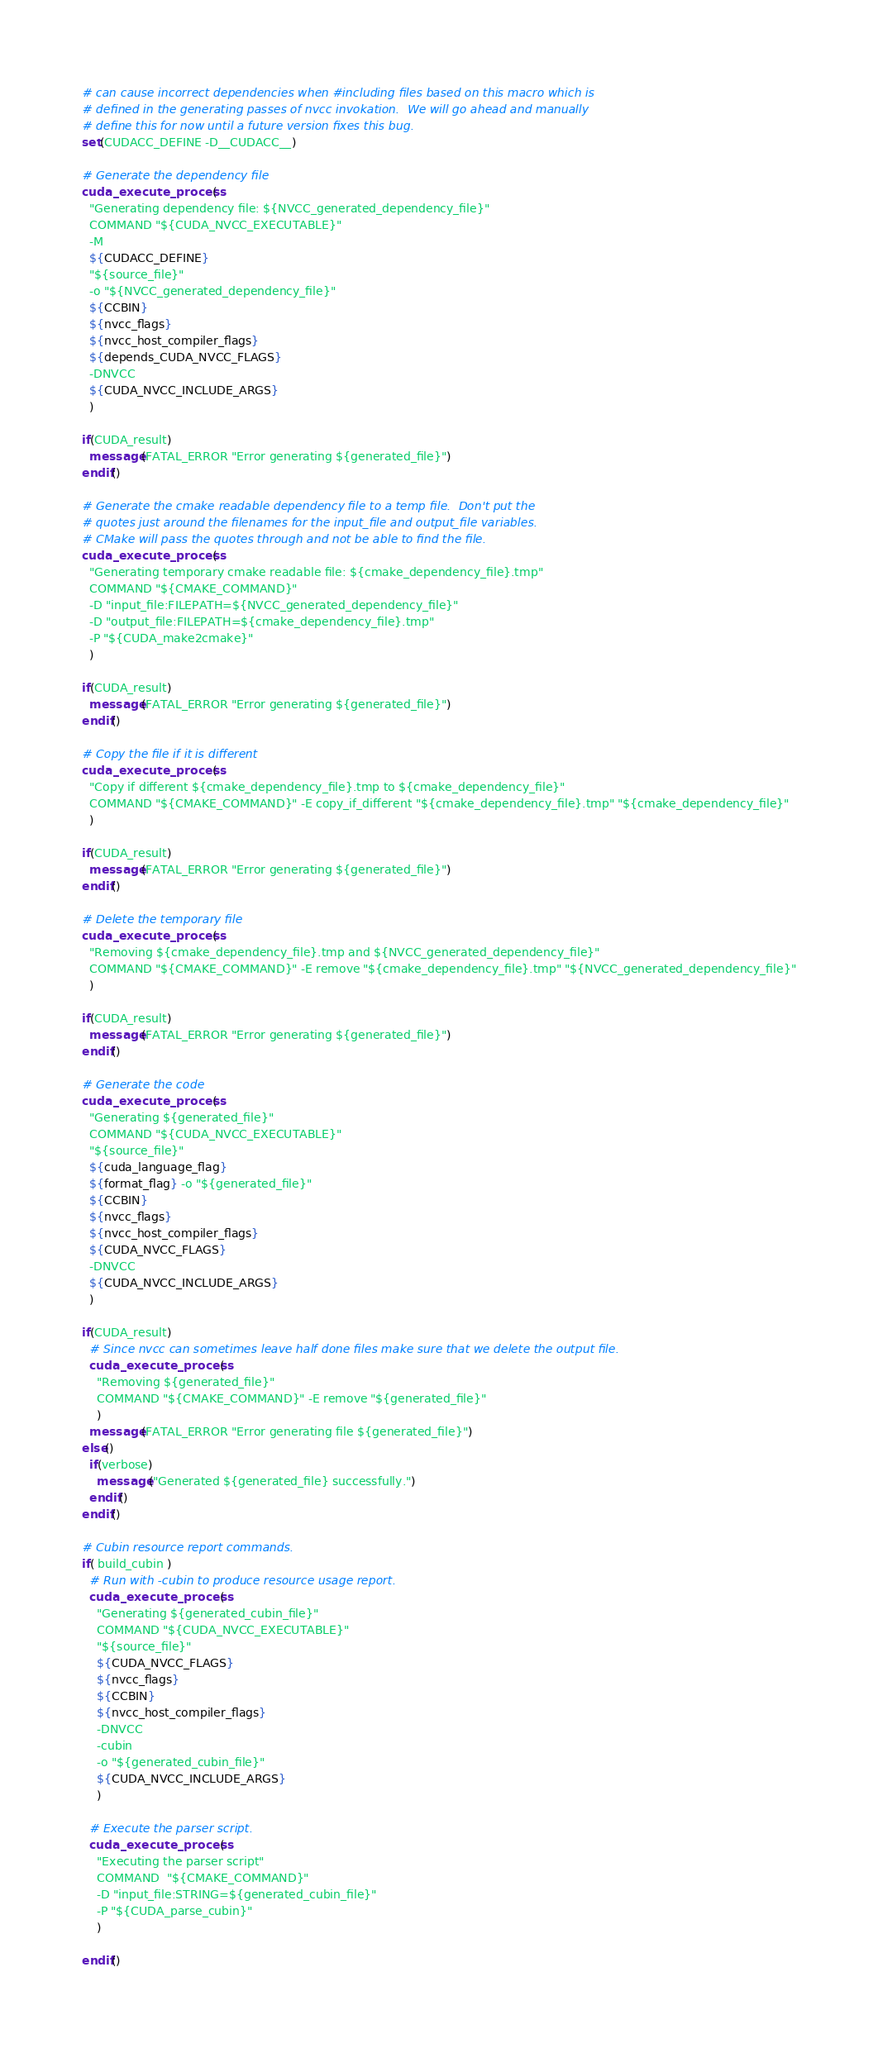Convert code to text. <code><loc_0><loc_0><loc_500><loc_500><_CMake_># can cause incorrect dependencies when #including files based on this macro which is
# defined in the generating passes of nvcc invokation.  We will go ahead and manually
# define this for now until a future version fixes this bug.
set(CUDACC_DEFINE -D__CUDACC__)

# Generate the dependency file
cuda_execute_process(
  "Generating dependency file: ${NVCC_generated_dependency_file}"
  COMMAND "${CUDA_NVCC_EXECUTABLE}"
  -M
  ${CUDACC_DEFINE}
  "${source_file}"
  -o "${NVCC_generated_dependency_file}"
  ${CCBIN}
  ${nvcc_flags}
  ${nvcc_host_compiler_flags}
  ${depends_CUDA_NVCC_FLAGS}
  -DNVCC
  ${CUDA_NVCC_INCLUDE_ARGS}
  )

if(CUDA_result)
  message(FATAL_ERROR "Error generating ${generated_file}")
endif()

# Generate the cmake readable dependency file to a temp file.  Don't put the
# quotes just around the filenames for the input_file and output_file variables.
# CMake will pass the quotes through and not be able to find the file.
cuda_execute_process(
  "Generating temporary cmake readable file: ${cmake_dependency_file}.tmp"
  COMMAND "${CMAKE_COMMAND}"
  -D "input_file:FILEPATH=${NVCC_generated_dependency_file}"
  -D "output_file:FILEPATH=${cmake_dependency_file}.tmp"
  -P "${CUDA_make2cmake}"
  )

if(CUDA_result)
  message(FATAL_ERROR "Error generating ${generated_file}")
endif()

# Copy the file if it is different
cuda_execute_process(
  "Copy if different ${cmake_dependency_file}.tmp to ${cmake_dependency_file}"
  COMMAND "${CMAKE_COMMAND}" -E copy_if_different "${cmake_dependency_file}.tmp" "${cmake_dependency_file}"
  )

if(CUDA_result)
  message(FATAL_ERROR "Error generating ${generated_file}")
endif()

# Delete the temporary file
cuda_execute_process(
  "Removing ${cmake_dependency_file}.tmp and ${NVCC_generated_dependency_file}"
  COMMAND "${CMAKE_COMMAND}" -E remove "${cmake_dependency_file}.tmp" "${NVCC_generated_dependency_file}"
  )

if(CUDA_result)
  message(FATAL_ERROR "Error generating ${generated_file}")
endif()

# Generate the code
cuda_execute_process(
  "Generating ${generated_file}"
  COMMAND "${CUDA_NVCC_EXECUTABLE}"
  "${source_file}"
  ${cuda_language_flag}
  ${format_flag} -o "${generated_file}"
  ${CCBIN}
  ${nvcc_flags}
  ${nvcc_host_compiler_flags}
  ${CUDA_NVCC_FLAGS}
  -DNVCC
  ${CUDA_NVCC_INCLUDE_ARGS}
  )

if(CUDA_result)
  # Since nvcc can sometimes leave half done files make sure that we delete the output file.
  cuda_execute_process(
    "Removing ${generated_file}"
    COMMAND "${CMAKE_COMMAND}" -E remove "${generated_file}"
    )
  message(FATAL_ERROR "Error generating file ${generated_file}")
else()
  if(verbose)
    message("Generated ${generated_file} successfully.")
  endif()
endif()

# Cubin resource report commands.
if( build_cubin )
  # Run with -cubin to produce resource usage report.
  cuda_execute_process(
    "Generating ${generated_cubin_file}"
    COMMAND "${CUDA_NVCC_EXECUTABLE}"
    "${source_file}"
    ${CUDA_NVCC_FLAGS}
    ${nvcc_flags}
    ${CCBIN}
    ${nvcc_host_compiler_flags}
    -DNVCC
    -cubin
    -o "${generated_cubin_file}"
    ${CUDA_NVCC_INCLUDE_ARGS}
    )

  # Execute the parser script.
  cuda_execute_process(
    "Executing the parser script"
    COMMAND  "${CMAKE_COMMAND}"
    -D "input_file:STRING=${generated_cubin_file}"
    -P "${CUDA_parse_cubin}"
    )

endif()
</code> 